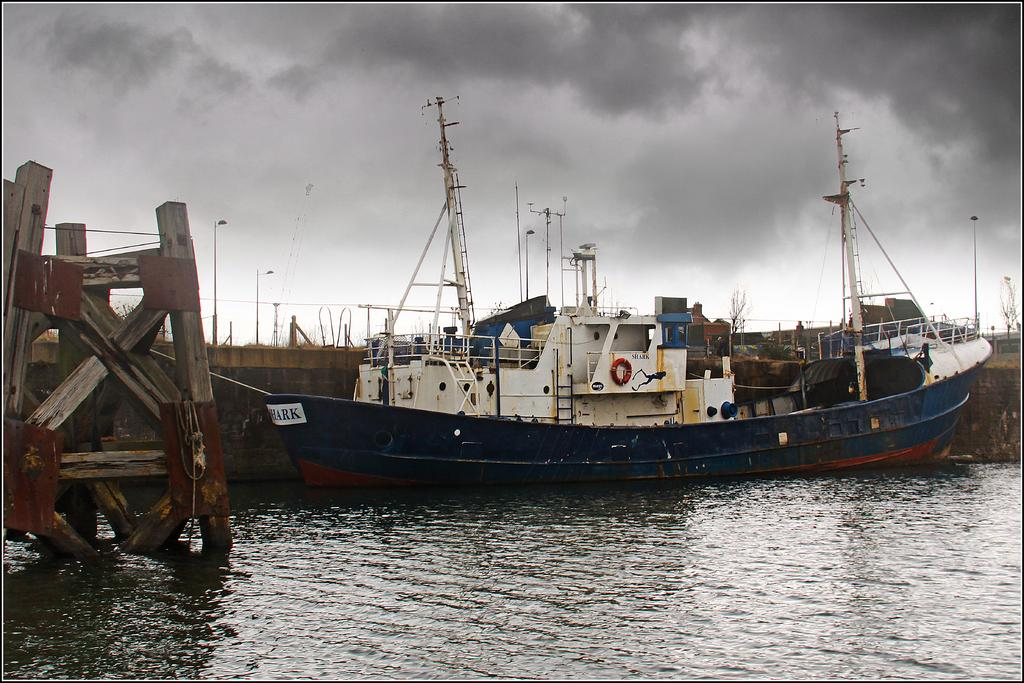What type of water body is present in the image? There is a water body in the image, but the specific type is not mentioned. What can be seen floating on the water body? There are ships and a wooden construction in the water body. Are there any other materials present in the water body? Yes, there are other materials in the water body. How would you describe the sky in the image? The sky is cloudy in the image. How many goldfish can be seen swimming in the water body in the image? There is no mention of goldfish in the image; the water body contains ships and a wooden construction. Can you see any wings in the image? There is no mention of wings or any flying objects in the image. 